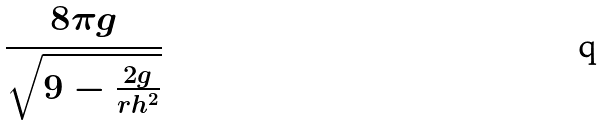Convert formula to latex. <formula><loc_0><loc_0><loc_500><loc_500>\frac { 8 \pi g } { \sqrt { 9 - \frac { 2 g } { r h ^ { 2 } } } }</formula> 